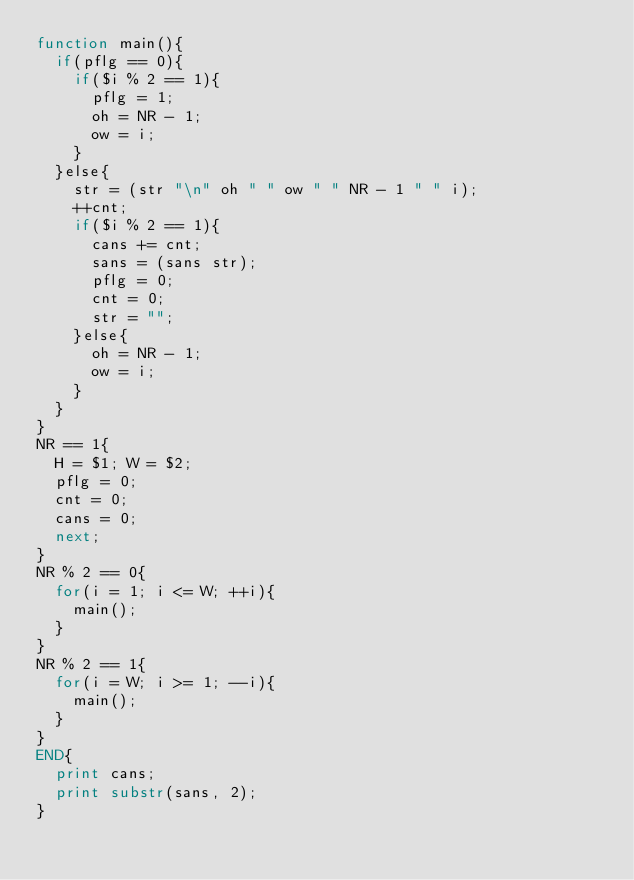<code> <loc_0><loc_0><loc_500><loc_500><_Awk_>function main(){
  if(pflg == 0){
    if($i % 2 == 1){
      pflg = 1;
      oh = NR - 1;
      ow = i;
    }
  }else{
    str = (str "\n" oh " " ow " " NR - 1 " " i);
    ++cnt;
    if($i % 2 == 1){
      cans += cnt;
      sans = (sans str);
      pflg = 0;
      cnt = 0;
      str = "";
    }else{
      oh = NR - 1;
      ow = i;
    }
  }
}
NR == 1{
  H = $1; W = $2;
  pflg = 0;
  cnt = 0;
  cans = 0;
  next;
}
NR % 2 == 0{
  for(i = 1; i <= W; ++i){
    main();
  }
}
NR % 2 == 1{
  for(i = W; i >= 1; --i){
    main();
  }
}
END{
  print cans;
  print substr(sans, 2);
}</code> 